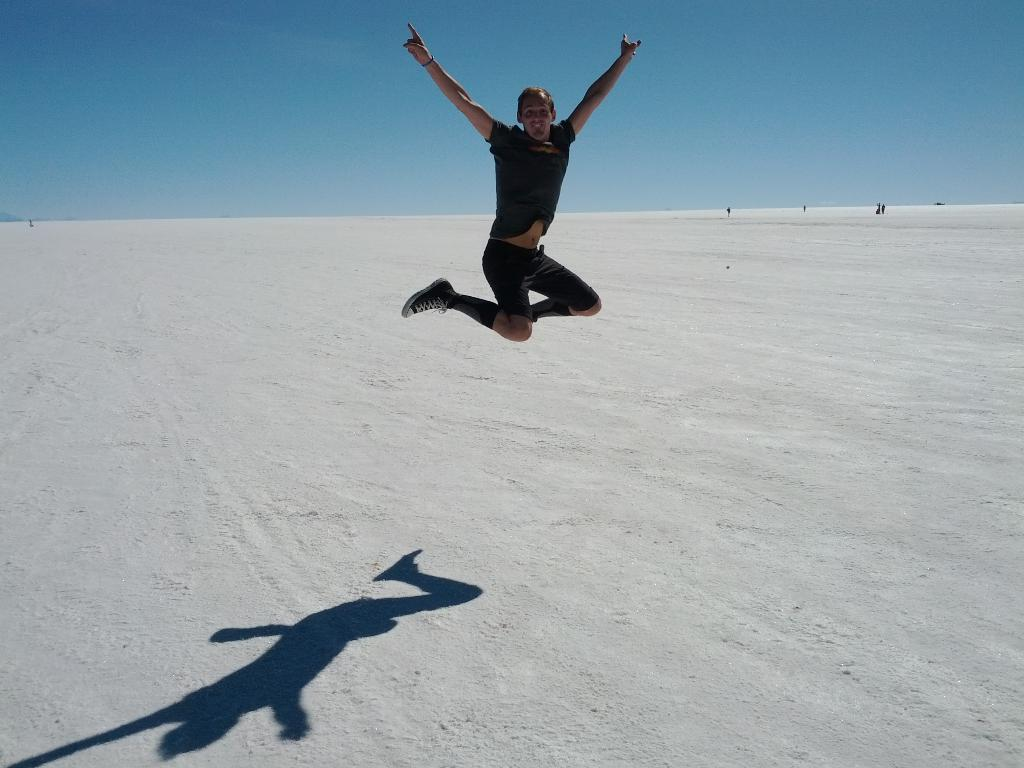What is happening to the man in the image? The man is in the air in the image. What can be seen on the ground below the man? The man's shadow is visible on the ground. What color is the sky in the image? The sky is blue at the top of the image. What type of cakes are being requested by the man in the image? There is no mention of cakes or a request in the image. What is the man's destination on his voyage in the image? There is no indication of a voyage or a destination in the image. 